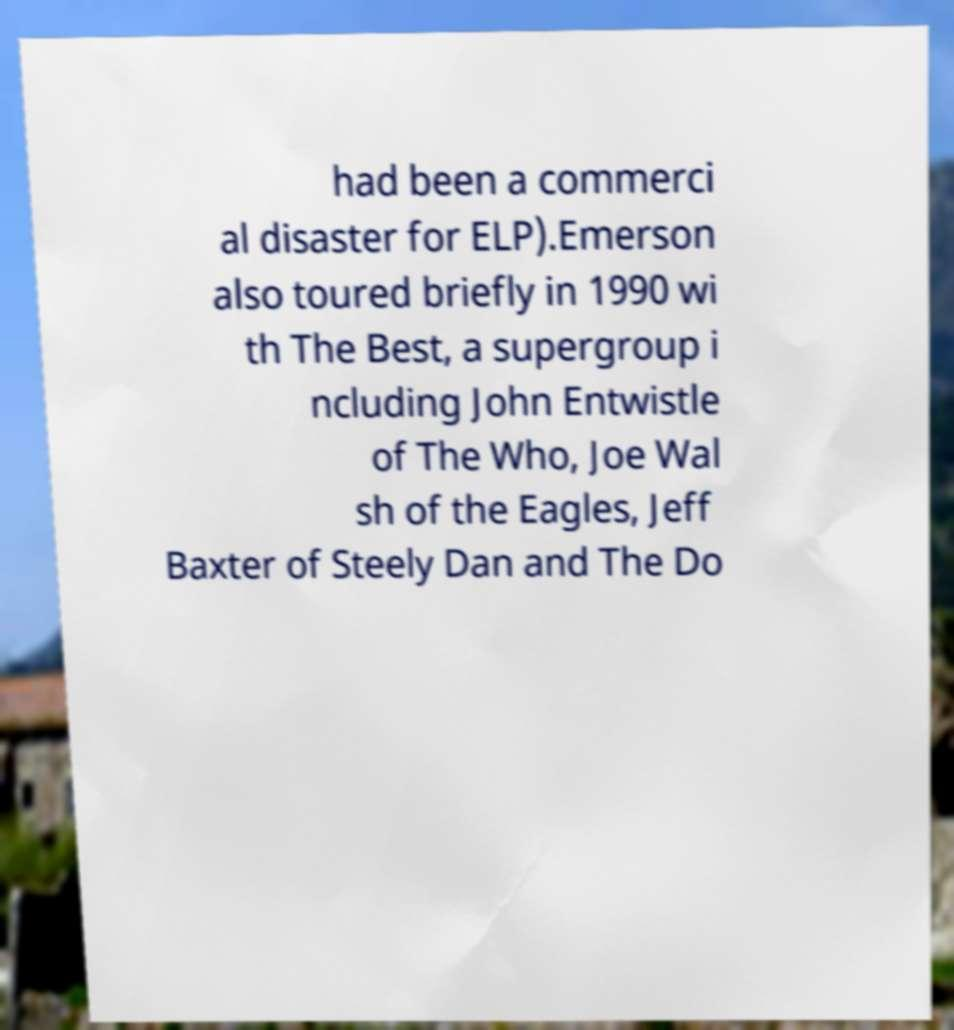There's text embedded in this image that I need extracted. Can you transcribe it verbatim? had been a commerci al disaster for ELP).Emerson also toured briefly in 1990 wi th The Best, a supergroup i ncluding John Entwistle of The Who, Joe Wal sh of the Eagles, Jeff Baxter of Steely Dan and The Do 